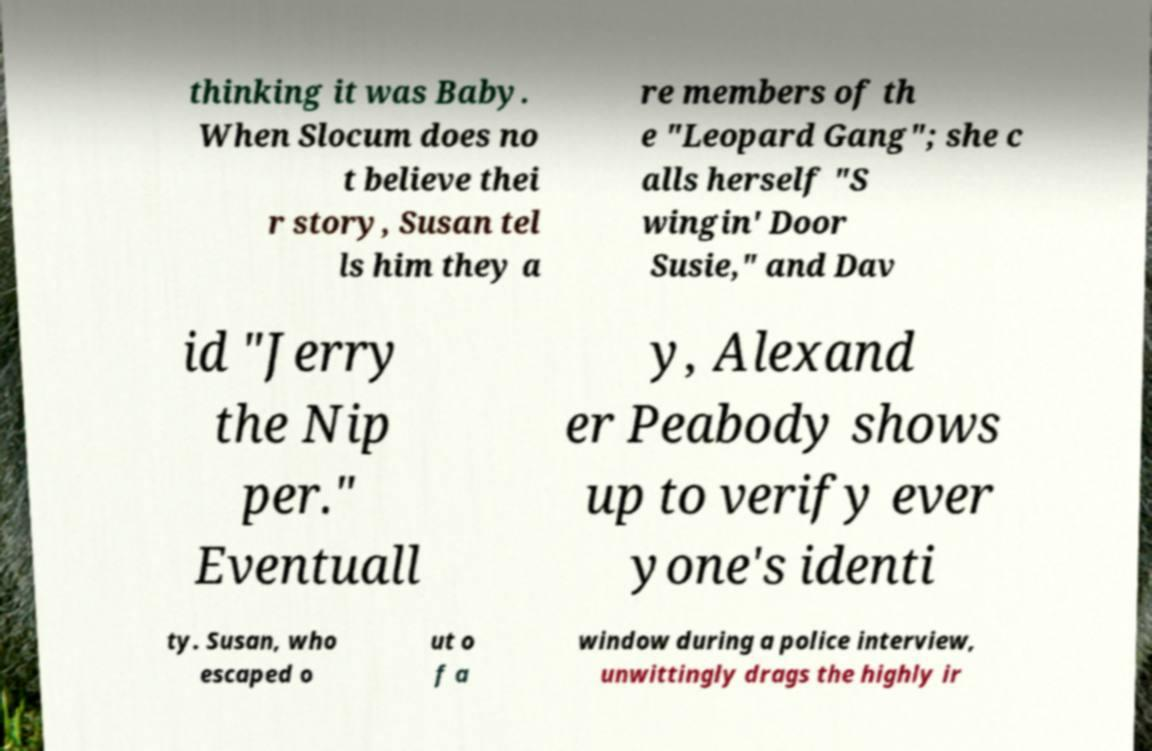Could you assist in decoding the text presented in this image and type it out clearly? thinking it was Baby. When Slocum does no t believe thei r story, Susan tel ls him they a re members of th e "Leopard Gang"; she c alls herself "S wingin' Door Susie," and Dav id "Jerry the Nip per." Eventuall y, Alexand er Peabody shows up to verify ever yone's identi ty. Susan, who escaped o ut o f a window during a police interview, unwittingly drags the highly ir 